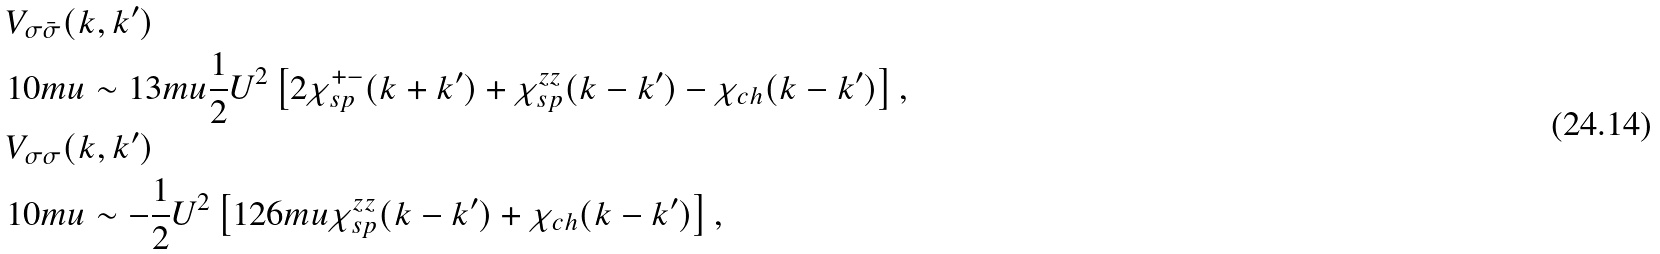Convert formula to latex. <formula><loc_0><loc_0><loc_500><loc_500>& V _ { \sigma \bar { \sigma } } ( k , k ^ { \prime } ) \\ & { 1 0 m u } \sim { 1 3 m u } \frac { 1 } { 2 } U ^ { 2 } \left [ 2 \chi _ { s p } ^ { + - } ( k + k ^ { \prime } ) + \chi _ { s p } ^ { z z } ( k - k ^ { \prime } ) - \chi _ { c h } ( k - k ^ { \prime } ) \right ] , \\ & V _ { \sigma \sigma } ( k , k ^ { \prime } ) \\ & { 1 0 m u } \sim - \frac { 1 } { 2 } U ^ { 2 } \left [ { 1 2 6 m u } \chi _ { s p } ^ { z z } ( k - k ^ { \prime } ) + \chi _ { c h } ( k - k ^ { \prime } ) \right ] ,</formula> 